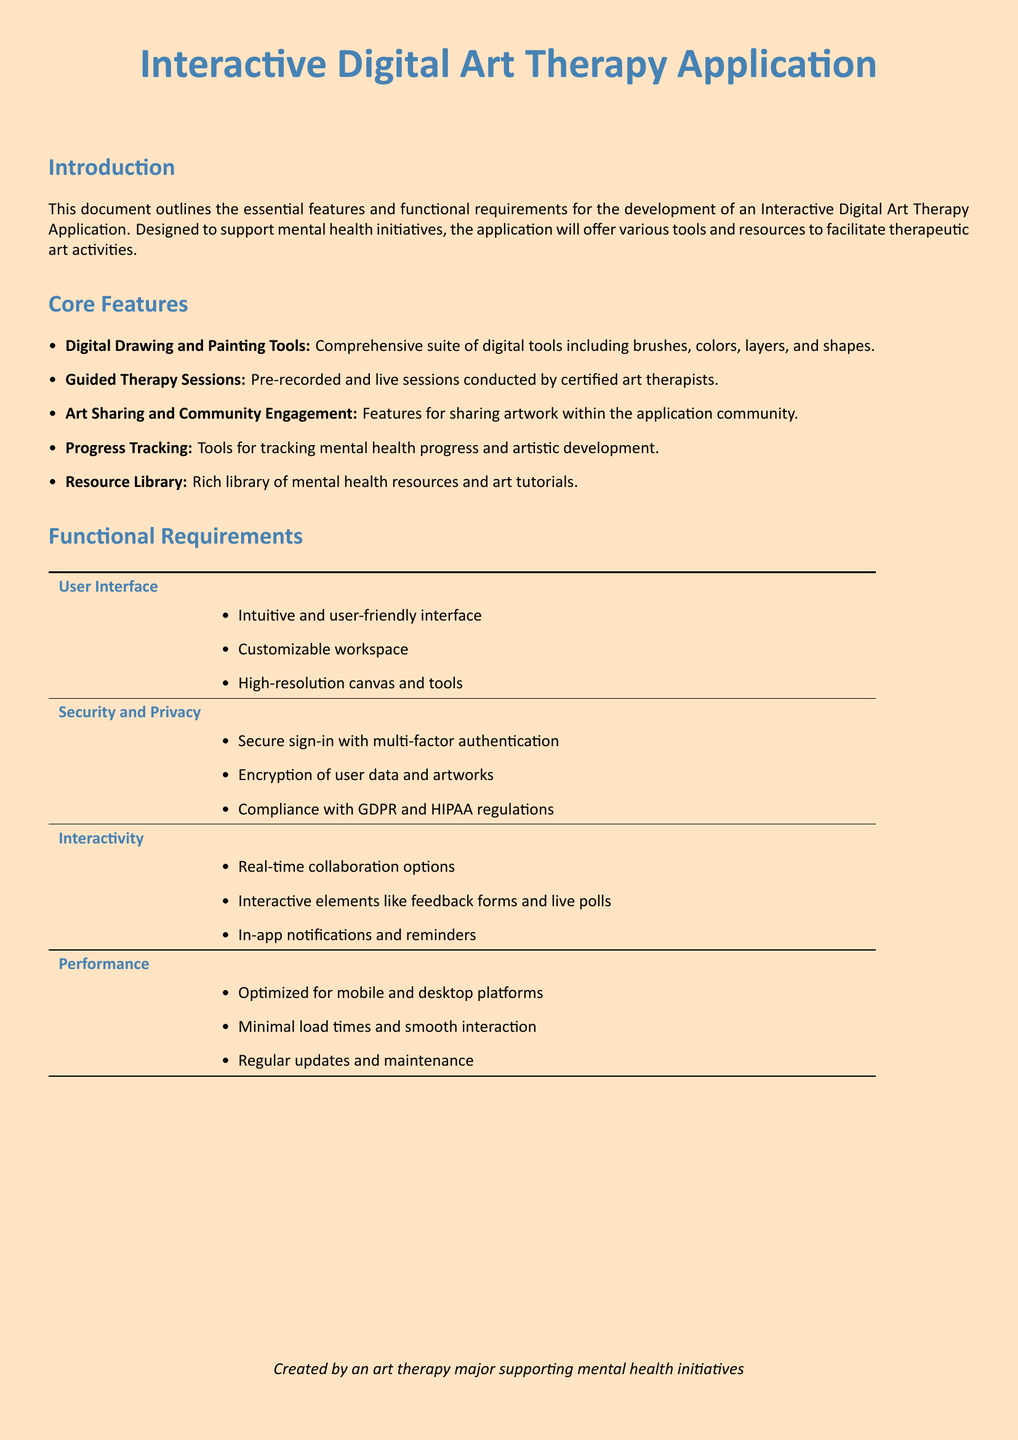What is the main focus of the Interactive Digital Art Therapy Application? The main focus is to support mental health initiatives through therapeutic art activities.
Answer: Support mental health initiatives How many core features are listed in the document? The document outlines five core features of the application.
Answer: Five What type of authentication is mentioned for user security? The application ensures secure sign-in with multi-factor authentication.
Answer: Multi-factor authentication Which requirement ensures compliance with regulations? The security and privacy section includes compliance with GDPR and HIPAA regulations.
Answer: GDPR and HIPAA compliance What device platforms is the application optimized for? The performance section mentions optimization for both mobile and desktop platforms.
Answer: Mobile and desktop What is included in the Resource Library of the application? The Resource Library includes mental health resources and art tutorials.
Answer: Mental health resources and art tutorials What interactive feature allows real-time collaboration? The document states that real-time collaboration options are available as an interactive feature.
Answer: Real-time collaboration options How is user data described in terms of security? User data and artworks are described as being encrypted for security purposes.
Answer: Encrypted 